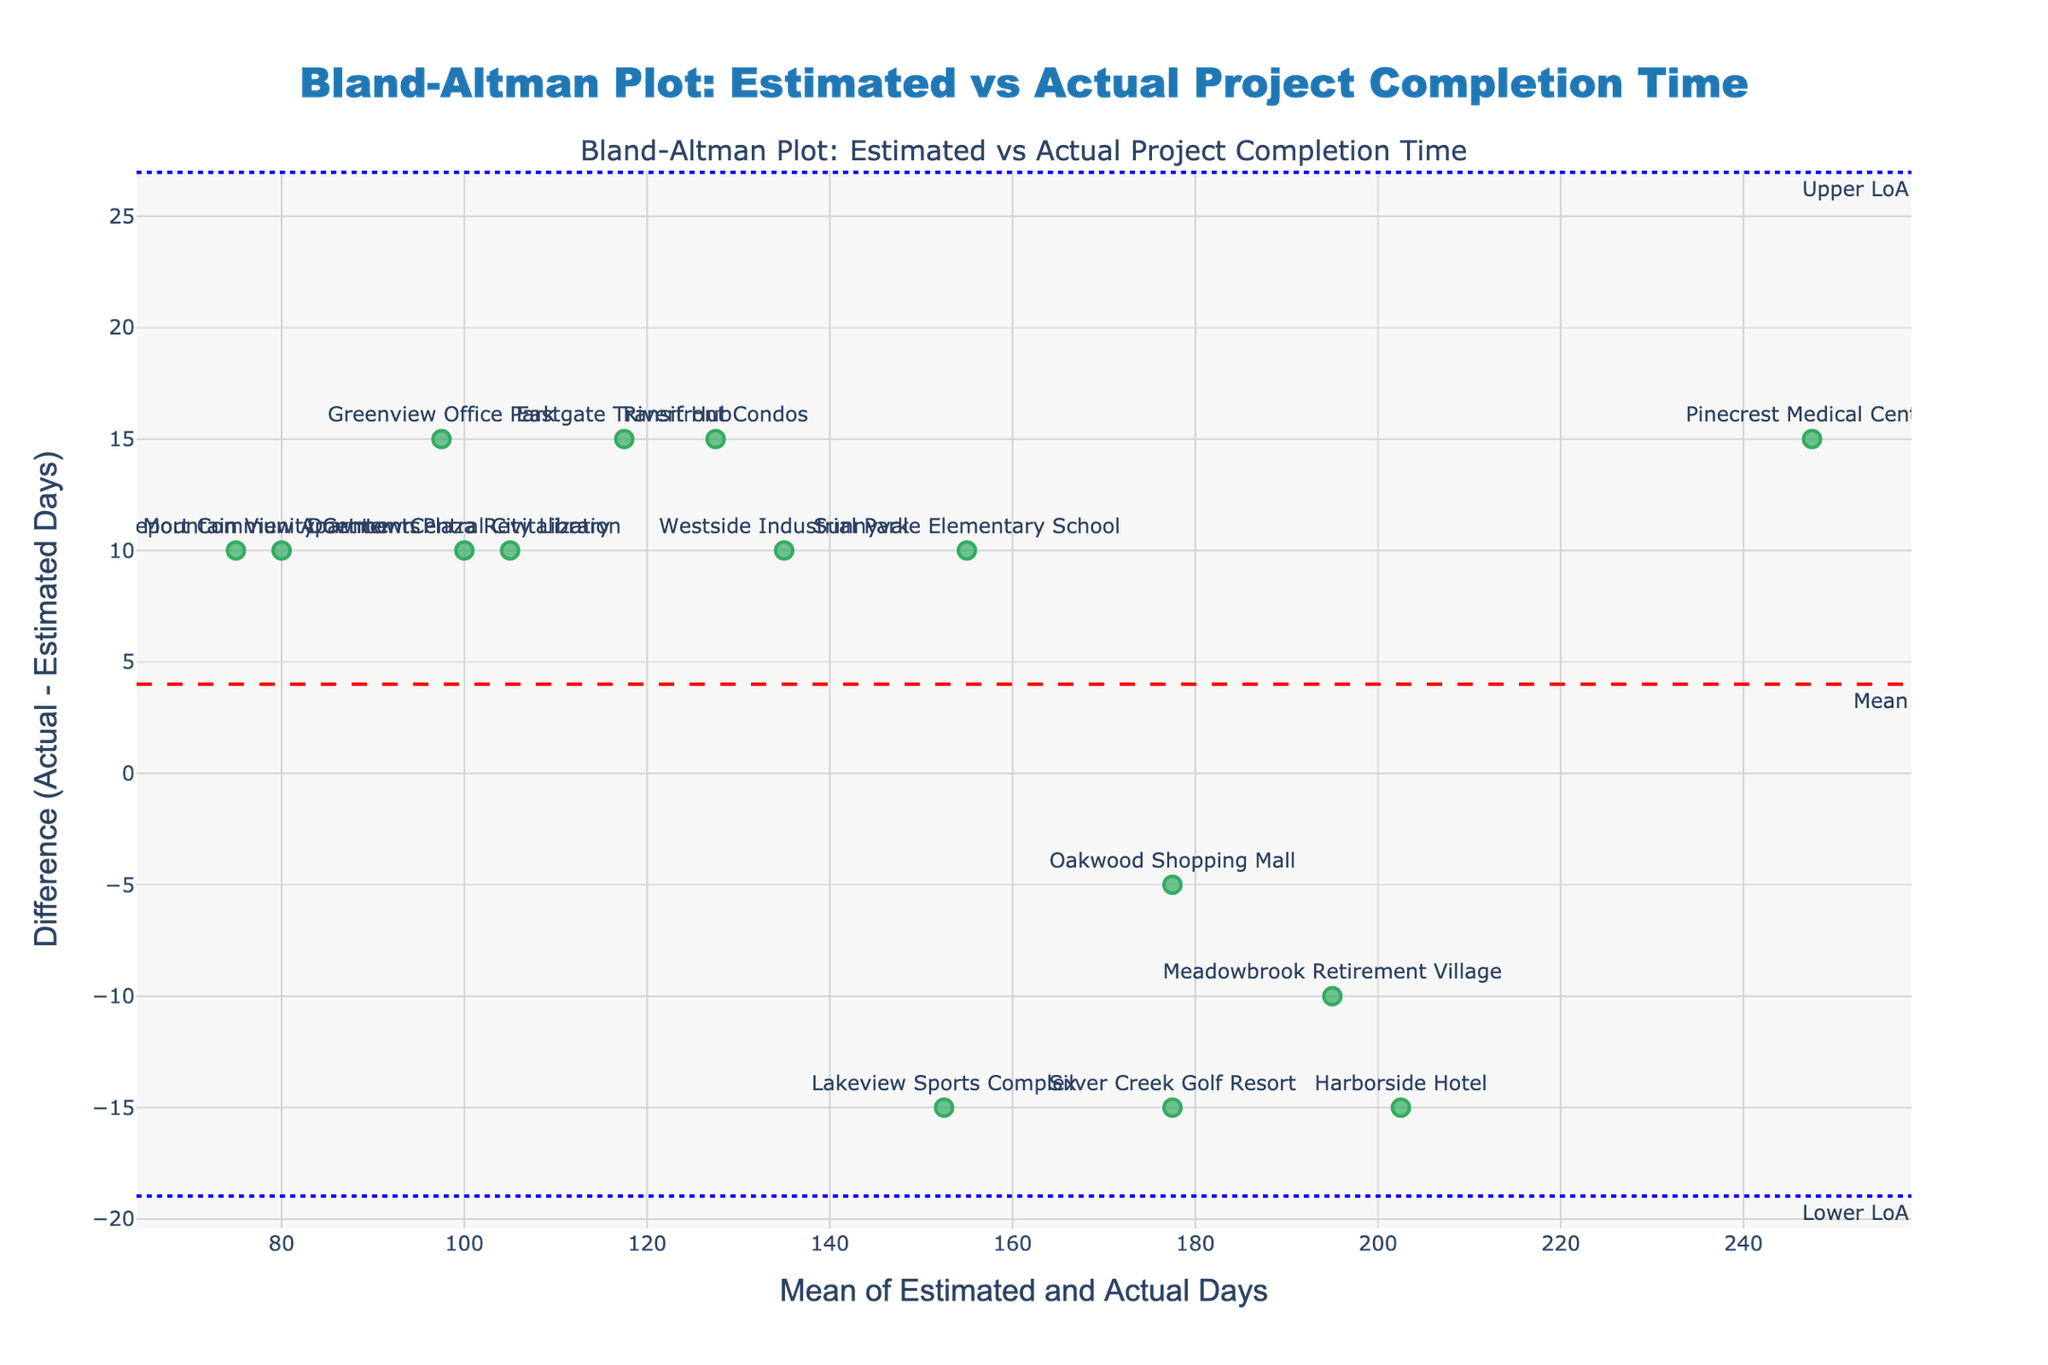what is the title of this plot? The title is presented at the top center of the plot. It reads "Bland-Altman Plot: Estimated vs Actual Project Completion Time."
Answer: Bland-Altman Plot: Estimated vs Actual Project Completion Time what do the x and y axis represent in this plot? The x-axis represents the "Mean of Estimated and Actual Days," while the y-axis represents the "Difference (Actual - Estimated Days)." These labels are displayed along the respective axes of the plot.
Answer: x-axis: Mean of Estimated and Actual Days, y-axis: Difference (Actual - Estimated Days) how many data points are plotted in the figure? Each project name is represented as one data point. By counting all the labels, there are 15 data points on the figure.
Answer: 15 what is the mean difference between actual and estimated project times? A dashed red line in the plot denotes the mean difference, along with a label "Mean." The actual value of this mean difference is seen on the y-axis where this line intersects the y-axis.
Answer: 0.67 days between which values do the limits of agreement fall? The plot features two blue dotted lines with annotations "Lower LoA" and "Upper LoA." These lines provide the values for the limits of agreement on the y-axis.
Answer: Lower LoA: -15.32 days, Upper LoA: 16.66 days Which project shows the largest positive difference between actual and estimated days? The plot shows the vertical difference i.e., the distance between the data point and the zero line on the y-axis. Pinecrest Medical Center is the highest above the zero line, representing the largest positive difference.
Answer: Pinecrest Medical Center Which project shows the largest negative difference between actual and estimated days? Look at the points below the zero line; Harborside Hotel is the furthest below, indicating the largest negative difference.
Answer: Harborside Hotel What does it mean if a project's data point is close to the mean difference line? Points close to the mean difference line indicate that the actual and estimated days for those projects are quite similar, as the difference is near the average difference of all projects
Answer: The actual and estimated days are similar What might it suggest if most points are within the limits of agreement? It suggests that the estimated project completion times can be considered fairly accurate and reliable, as most differences fall within an acceptable range.
Answer: Estimates are fairly accurate How can you identify outliers in this plot? Outliers are identified as points that fall outside the limits of agreement, which are defined by the blue dotted lines. These points indicate significant deviations between estimated and actual completion times.
Answer: Points outside the blue dotted lines 